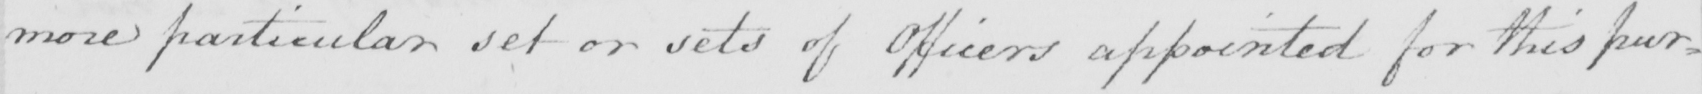Transcribe the text shown in this historical manuscript line. more particular set or sets of Officers appointed for this pur= 